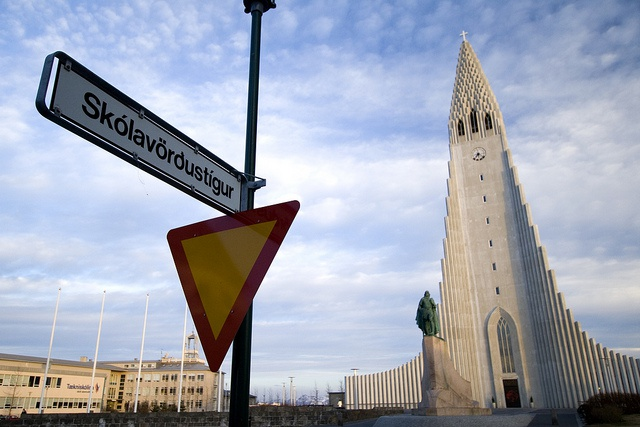Describe the objects in this image and their specific colors. I can see a clock in darkgray and gray tones in this image. 